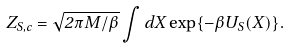<formula> <loc_0><loc_0><loc_500><loc_500>Z _ { S , c } = \sqrt { 2 \pi M / \beta } \int d X \exp \{ - \beta U _ { S } ( X ) \} .</formula> 